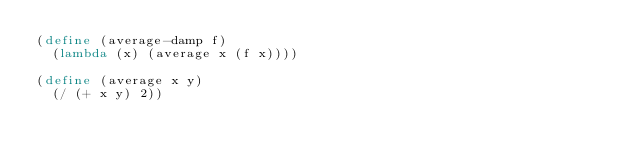Convert code to text. <code><loc_0><loc_0><loc_500><loc_500><_Scheme_>(define (average-damp f)
  (lambda (x) (average x (f x))))

(define (average x y)
  (/ (+ x y) 2))</code> 